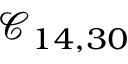<formula> <loc_0><loc_0><loc_500><loc_500>\mathcal { C } _ { 1 4 , 3 0 }</formula> 